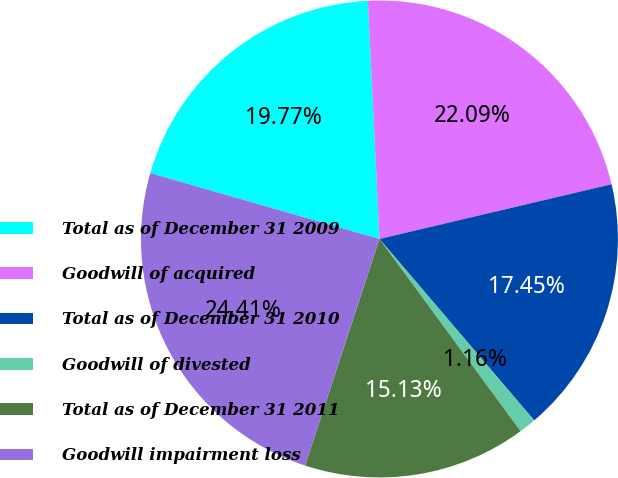Convert chart. <chart><loc_0><loc_0><loc_500><loc_500><pie_chart><fcel>Total as of December 31 2009<fcel>Goodwill of acquired<fcel>Total as of December 31 2010<fcel>Goodwill of divested<fcel>Total as of December 31 2011<fcel>Goodwill impairment loss<nl><fcel>19.77%<fcel>22.09%<fcel>17.45%<fcel>1.16%<fcel>15.13%<fcel>24.41%<nl></chart> 